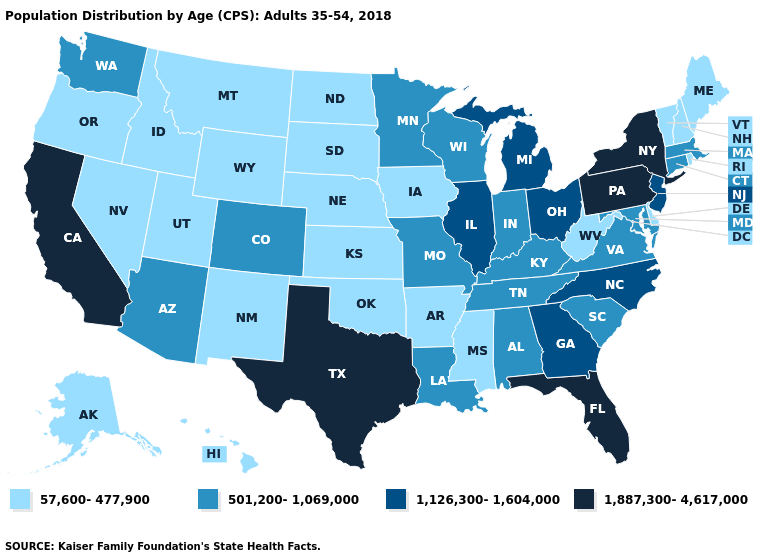Among the states that border Colorado , which have the highest value?
Be succinct. Arizona. Name the states that have a value in the range 1,887,300-4,617,000?
Give a very brief answer. California, Florida, New York, Pennsylvania, Texas. Does Kentucky have a higher value than Virginia?
Short answer required. No. Which states hav the highest value in the West?
Concise answer only. California. Which states have the highest value in the USA?
Concise answer only. California, Florida, New York, Pennsylvania, Texas. What is the value of Maryland?
Concise answer only. 501,200-1,069,000. Name the states that have a value in the range 57,600-477,900?
Answer briefly. Alaska, Arkansas, Delaware, Hawaii, Idaho, Iowa, Kansas, Maine, Mississippi, Montana, Nebraska, Nevada, New Hampshire, New Mexico, North Dakota, Oklahoma, Oregon, Rhode Island, South Dakota, Utah, Vermont, West Virginia, Wyoming. What is the lowest value in states that border Vermont?
Keep it brief. 57,600-477,900. Name the states that have a value in the range 1,126,300-1,604,000?
Concise answer only. Georgia, Illinois, Michigan, New Jersey, North Carolina, Ohio. Does the map have missing data?
Give a very brief answer. No. Name the states that have a value in the range 1,887,300-4,617,000?
Answer briefly. California, Florida, New York, Pennsylvania, Texas. What is the value of Arkansas?
Concise answer only. 57,600-477,900. Does Florida have the highest value in the South?
Write a very short answer. Yes. Does the map have missing data?
Concise answer only. No. What is the lowest value in the MidWest?
Concise answer only. 57,600-477,900. 